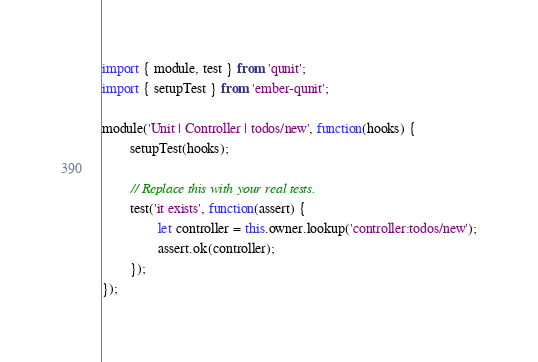Convert code to text. <code><loc_0><loc_0><loc_500><loc_500><_JavaScript_>import { module, test } from 'qunit';
import { setupTest } from 'ember-qunit';

module('Unit | Controller | todos/new', function(hooks) {
        setupTest(hooks);

        // Replace this with your real tests.
        test('it exists', function(assert) {
                let controller = this.owner.lookup('controller:todos/new');
                assert.ok(controller);
        });
});
</code> 